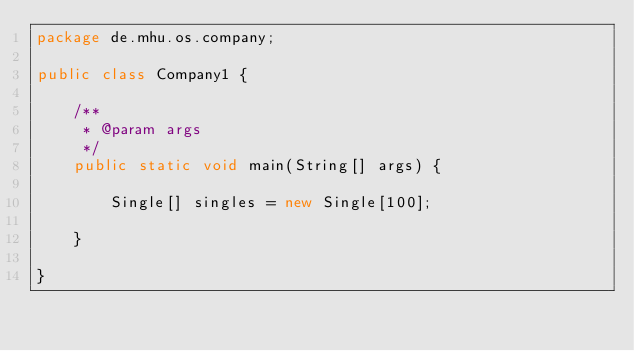<code> <loc_0><loc_0><loc_500><loc_500><_Java_>package de.mhu.os.company;

public class Company1 {

	/**
	 * @param args
	 */
	public static void main(String[] args) {
		
		Single[] singles = new Single[100];
		
	}

}
</code> 